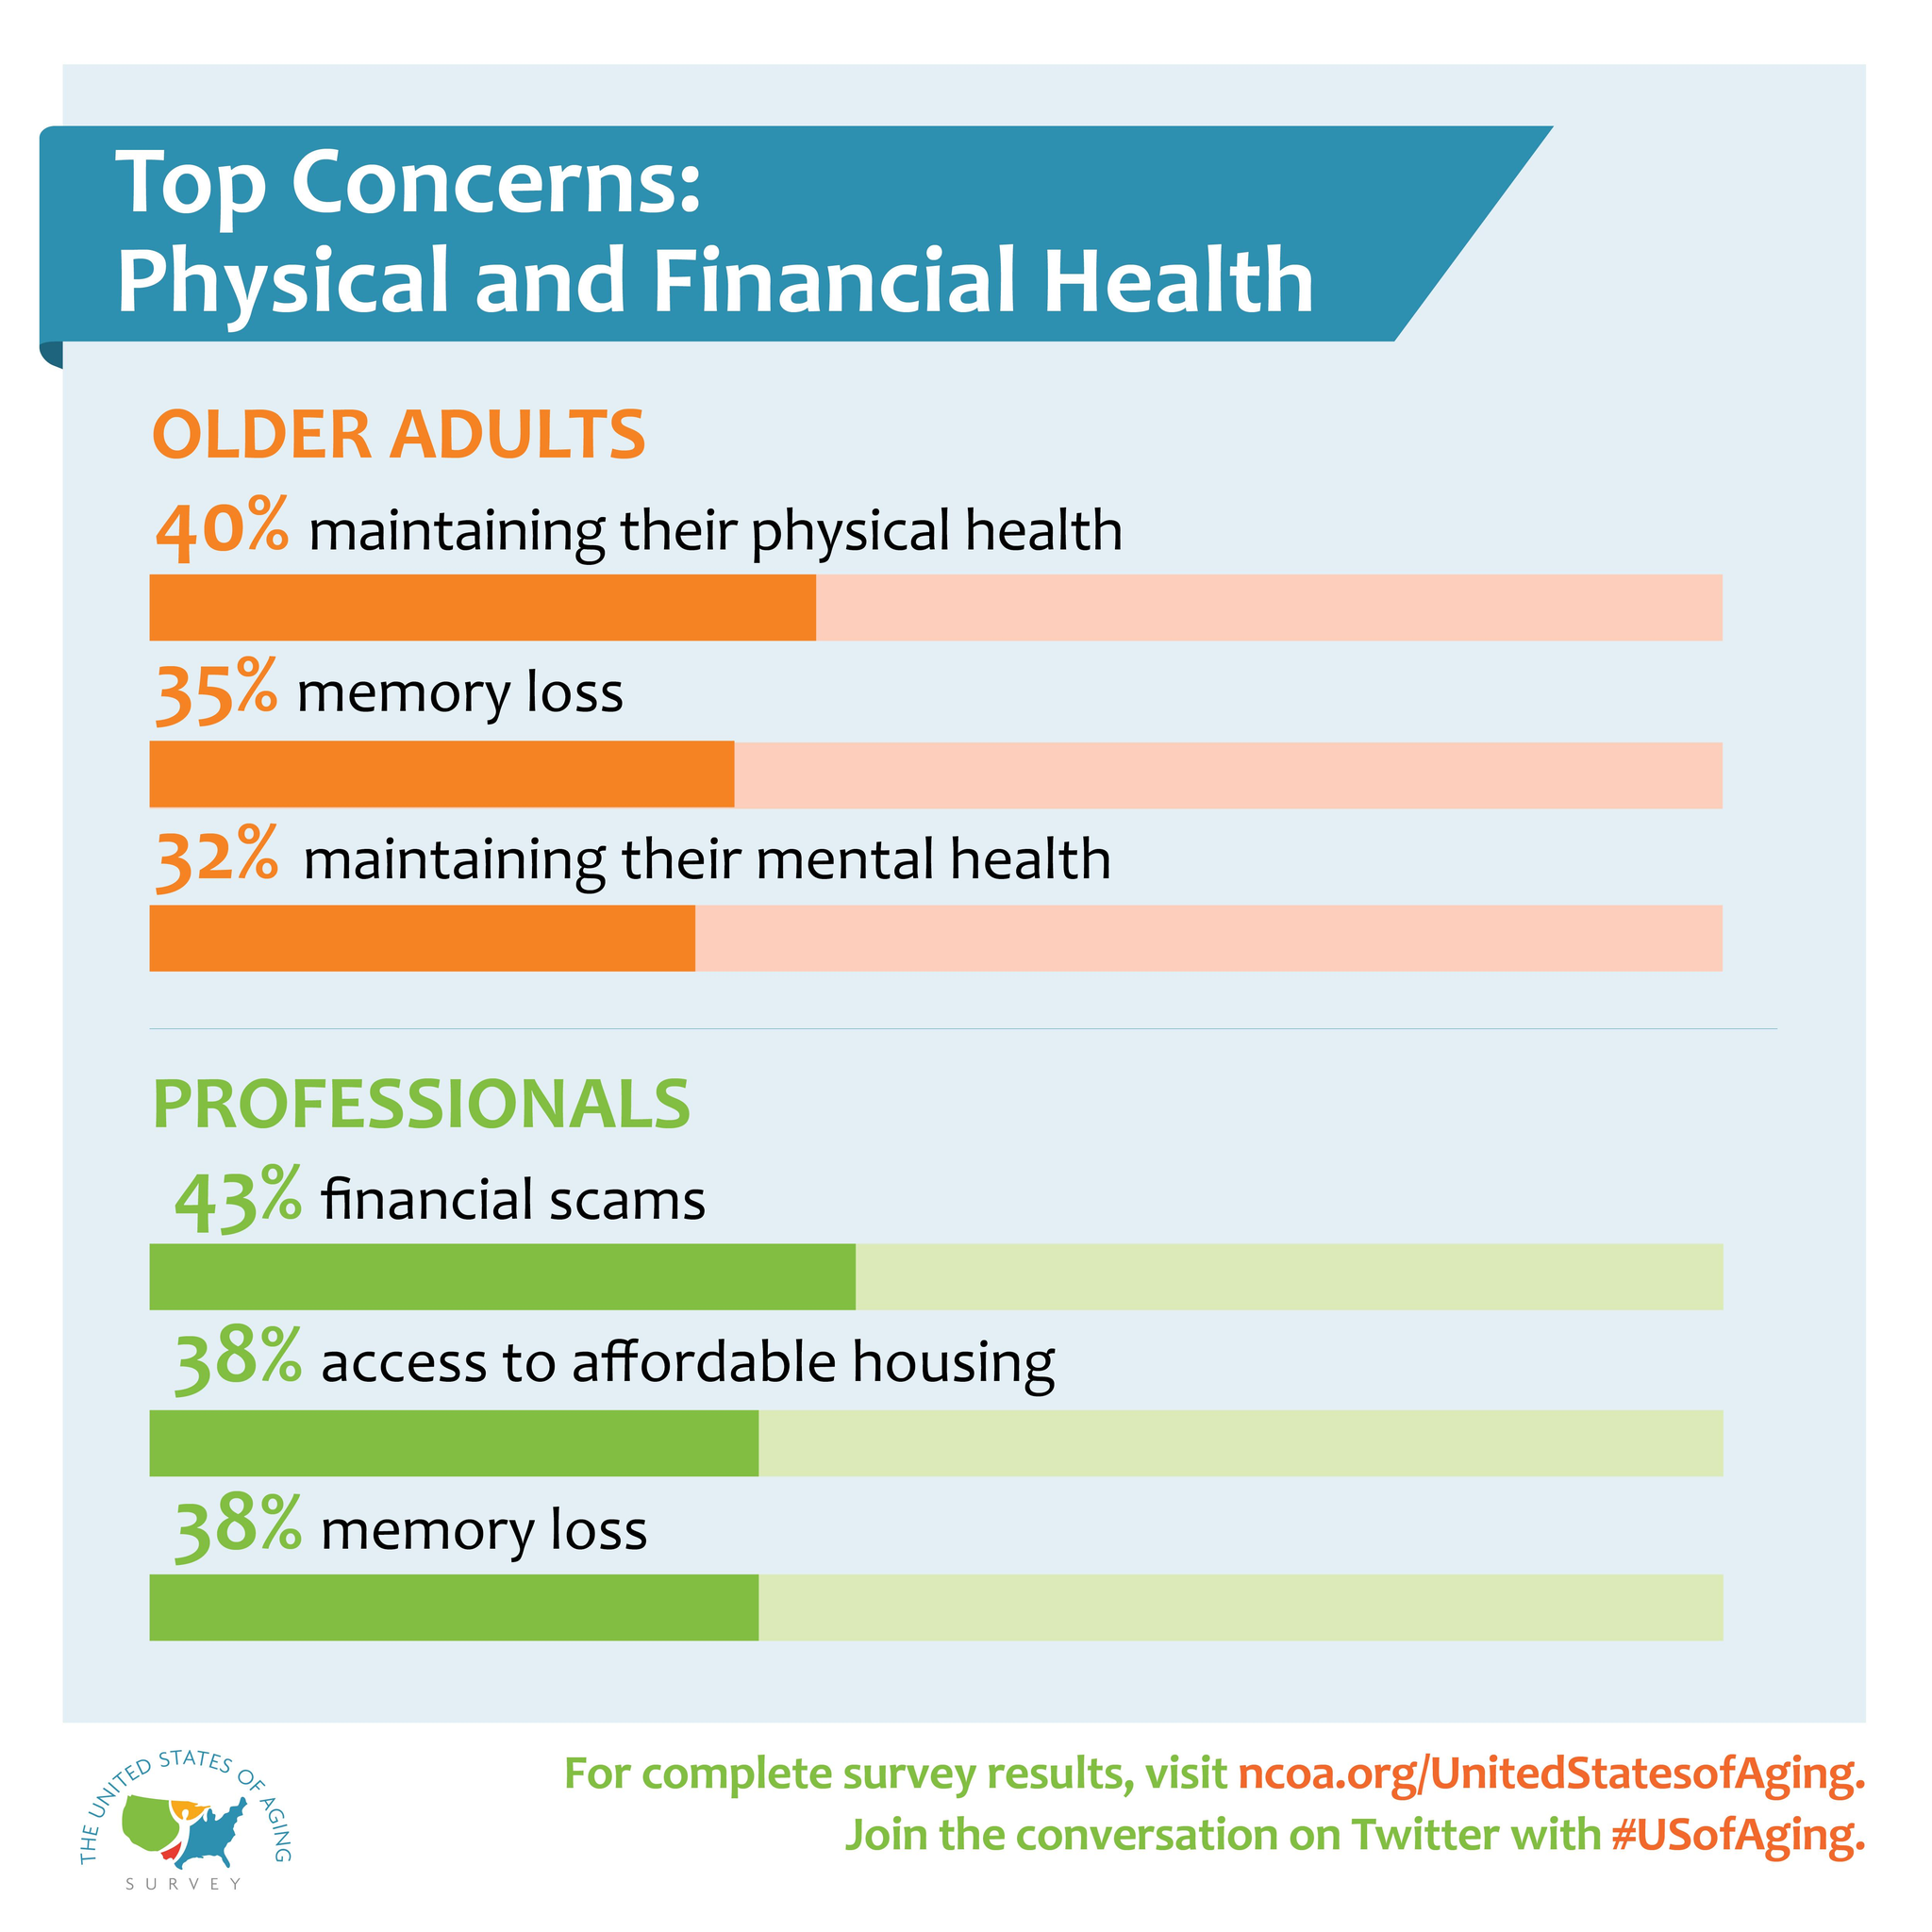Give some essential details in this illustration. Maintaining physical health is the top concern of older adults. 